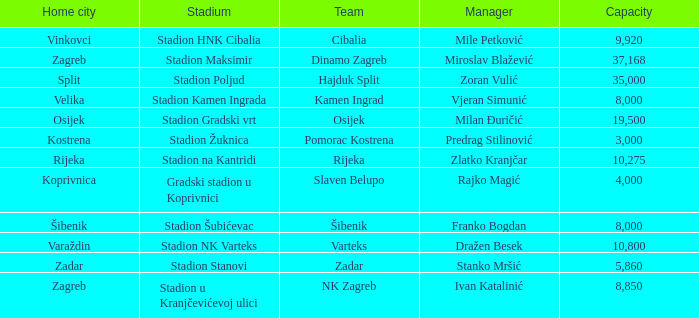What team has a home city of Koprivnica? Slaven Belupo. 